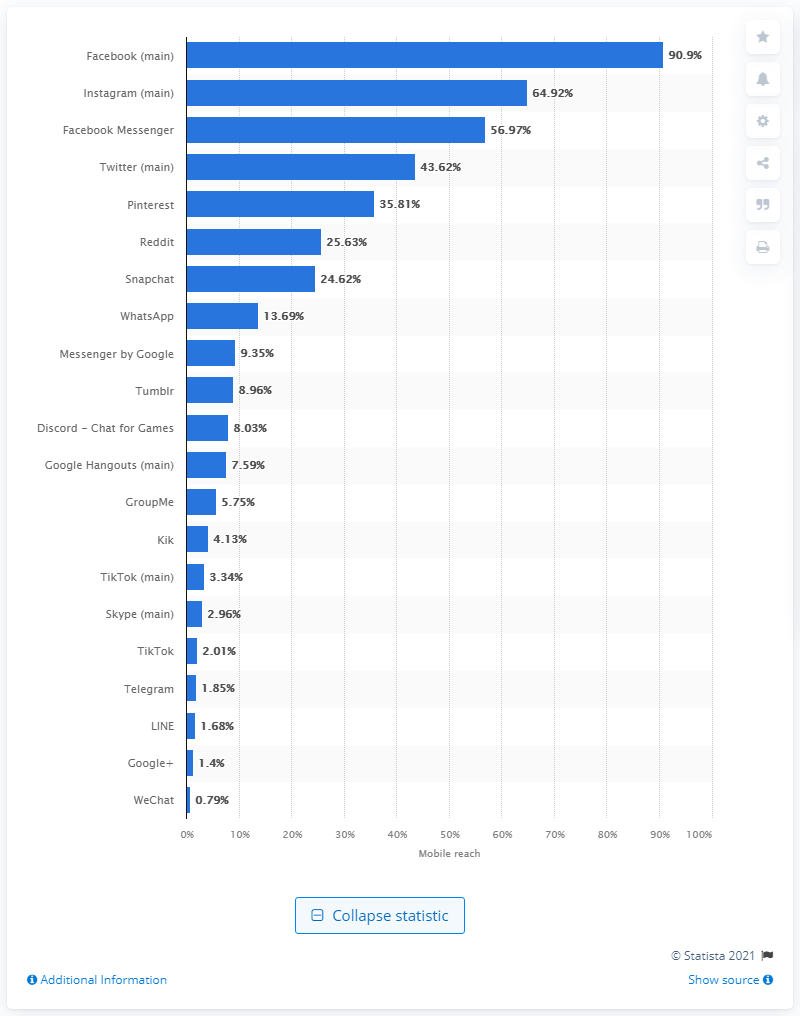Indicate a few pertinent items in this graphic. In September 2019, 90.9% of U.S. mobile users accessed the Facebook app. 